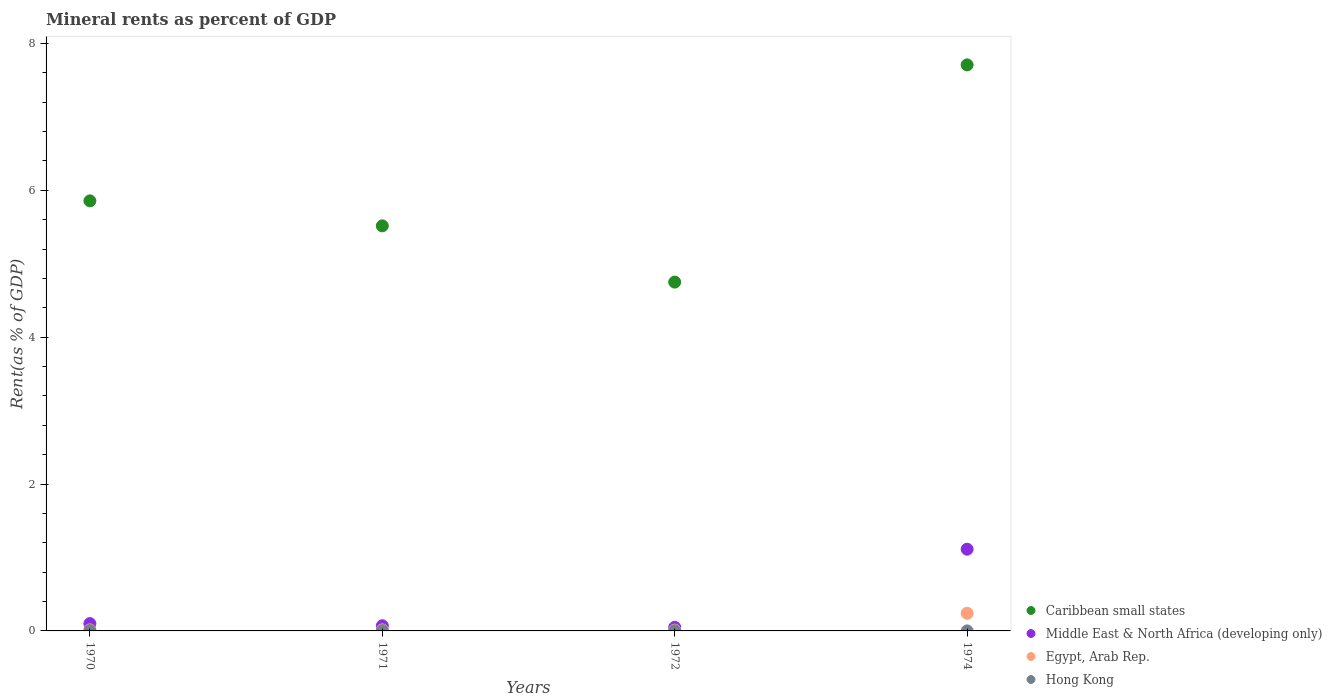Is the number of dotlines equal to the number of legend labels?
Your answer should be compact. Yes. What is the mineral rent in Caribbean small states in 1972?
Keep it short and to the point. 4.75. Across all years, what is the maximum mineral rent in Middle East & North Africa (developing only)?
Offer a very short reply. 1.11. Across all years, what is the minimum mineral rent in Hong Kong?
Your response must be concise. 0. In which year was the mineral rent in Egypt, Arab Rep. maximum?
Provide a short and direct response. 1974. What is the total mineral rent in Egypt, Arab Rep. in the graph?
Make the answer very short. 0.28. What is the difference between the mineral rent in Egypt, Arab Rep. in 1972 and that in 1974?
Provide a short and direct response. -0.23. What is the difference between the mineral rent in Middle East & North Africa (developing only) in 1971 and the mineral rent in Hong Kong in 1974?
Keep it short and to the point. 0.07. What is the average mineral rent in Middle East & North Africa (developing only) per year?
Offer a terse response. 0.33. In the year 1974, what is the difference between the mineral rent in Caribbean small states and mineral rent in Egypt, Arab Rep.?
Your response must be concise. 7.47. In how many years, is the mineral rent in Hong Kong greater than 4.8 %?
Make the answer very short. 0. What is the ratio of the mineral rent in Hong Kong in 1971 to that in 1974?
Offer a very short reply. 9.86. What is the difference between the highest and the second highest mineral rent in Egypt, Arab Rep.?
Give a very brief answer. 0.23. What is the difference between the highest and the lowest mineral rent in Caribbean small states?
Keep it short and to the point. 2.96. In how many years, is the mineral rent in Hong Kong greater than the average mineral rent in Hong Kong taken over all years?
Offer a very short reply. 2. Is the sum of the mineral rent in Middle East & North Africa (developing only) in 1972 and 1974 greater than the maximum mineral rent in Caribbean small states across all years?
Make the answer very short. No. Is it the case that in every year, the sum of the mineral rent in Middle East & North Africa (developing only) and mineral rent in Hong Kong  is greater than the mineral rent in Caribbean small states?
Make the answer very short. No. Is the mineral rent in Middle East & North Africa (developing only) strictly greater than the mineral rent in Caribbean small states over the years?
Provide a succinct answer. No. How many dotlines are there?
Provide a succinct answer. 4. How many years are there in the graph?
Offer a very short reply. 4. Are the values on the major ticks of Y-axis written in scientific E-notation?
Provide a succinct answer. No. What is the title of the graph?
Offer a terse response. Mineral rents as percent of GDP. What is the label or title of the Y-axis?
Your answer should be very brief. Rent(as % of GDP). What is the Rent(as % of GDP) in Caribbean small states in 1970?
Provide a short and direct response. 5.86. What is the Rent(as % of GDP) in Middle East & North Africa (developing only) in 1970?
Your response must be concise. 0.1. What is the Rent(as % of GDP) of Egypt, Arab Rep. in 1970?
Your answer should be compact. 0.01. What is the Rent(as % of GDP) in Hong Kong in 1970?
Give a very brief answer. 0. What is the Rent(as % of GDP) of Caribbean small states in 1971?
Give a very brief answer. 5.52. What is the Rent(as % of GDP) in Middle East & North Africa (developing only) in 1971?
Keep it short and to the point. 0.07. What is the Rent(as % of GDP) in Egypt, Arab Rep. in 1971?
Your answer should be compact. 0.02. What is the Rent(as % of GDP) of Hong Kong in 1971?
Your answer should be very brief. 0. What is the Rent(as % of GDP) of Caribbean small states in 1972?
Ensure brevity in your answer.  4.75. What is the Rent(as % of GDP) in Middle East & North Africa (developing only) in 1972?
Your answer should be very brief. 0.05. What is the Rent(as % of GDP) of Egypt, Arab Rep. in 1972?
Your answer should be very brief. 0.01. What is the Rent(as % of GDP) of Hong Kong in 1972?
Make the answer very short. 0. What is the Rent(as % of GDP) of Caribbean small states in 1974?
Offer a very short reply. 7.71. What is the Rent(as % of GDP) of Middle East & North Africa (developing only) in 1974?
Ensure brevity in your answer.  1.11. What is the Rent(as % of GDP) in Egypt, Arab Rep. in 1974?
Offer a terse response. 0.24. What is the Rent(as % of GDP) of Hong Kong in 1974?
Your response must be concise. 0. Across all years, what is the maximum Rent(as % of GDP) of Caribbean small states?
Offer a very short reply. 7.71. Across all years, what is the maximum Rent(as % of GDP) of Middle East & North Africa (developing only)?
Offer a terse response. 1.11. Across all years, what is the maximum Rent(as % of GDP) of Egypt, Arab Rep.?
Give a very brief answer. 0.24. Across all years, what is the maximum Rent(as % of GDP) of Hong Kong?
Your response must be concise. 0. Across all years, what is the minimum Rent(as % of GDP) of Caribbean small states?
Your answer should be compact. 4.75. Across all years, what is the minimum Rent(as % of GDP) of Middle East & North Africa (developing only)?
Your answer should be compact. 0.05. Across all years, what is the minimum Rent(as % of GDP) in Egypt, Arab Rep.?
Your response must be concise. 0.01. Across all years, what is the minimum Rent(as % of GDP) in Hong Kong?
Give a very brief answer. 0. What is the total Rent(as % of GDP) in Caribbean small states in the graph?
Your answer should be compact. 23.83. What is the total Rent(as % of GDP) in Middle East & North Africa (developing only) in the graph?
Ensure brevity in your answer.  1.33. What is the total Rent(as % of GDP) of Egypt, Arab Rep. in the graph?
Give a very brief answer. 0.28. What is the total Rent(as % of GDP) in Hong Kong in the graph?
Your answer should be compact. 0.01. What is the difference between the Rent(as % of GDP) of Caribbean small states in 1970 and that in 1971?
Your answer should be very brief. 0.34. What is the difference between the Rent(as % of GDP) of Middle East & North Africa (developing only) in 1970 and that in 1971?
Your answer should be very brief. 0.03. What is the difference between the Rent(as % of GDP) in Egypt, Arab Rep. in 1970 and that in 1971?
Provide a short and direct response. -0. What is the difference between the Rent(as % of GDP) of Hong Kong in 1970 and that in 1971?
Give a very brief answer. 0. What is the difference between the Rent(as % of GDP) in Caribbean small states in 1970 and that in 1972?
Offer a terse response. 1.11. What is the difference between the Rent(as % of GDP) of Middle East & North Africa (developing only) in 1970 and that in 1972?
Your answer should be very brief. 0.05. What is the difference between the Rent(as % of GDP) in Egypt, Arab Rep. in 1970 and that in 1972?
Provide a short and direct response. 0. What is the difference between the Rent(as % of GDP) in Hong Kong in 1970 and that in 1972?
Your response must be concise. 0. What is the difference between the Rent(as % of GDP) of Caribbean small states in 1970 and that in 1974?
Offer a very short reply. -1.85. What is the difference between the Rent(as % of GDP) in Middle East & North Africa (developing only) in 1970 and that in 1974?
Offer a very short reply. -1.01. What is the difference between the Rent(as % of GDP) in Egypt, Arab Rep. in 1970 and that in 1974?
Offer a very short reply. -0.23. What is the difference between the Rent(as % of GDP) of Hong Kong in 1970 and that in 1974?
Your answer should be very brief. 0. What is the difference between the Rent(as % of GDP) of Caribbean small states in 1971 and that in 1972?
Your response must be concise. 0.77. What is the difference between the Rent(as % of GDP) of Middle East & North Africa (developing only) in 1971 and that in 1972?
Keep it short and to the point. 0.02. What is the difference between the Rent(as % of GDP) of Egypt, Arab Rep. in 1971 and that in 1972?
Your answer should be very brief. 0. What is the difference between the Rent(as % of GDP) of Hong Kong in 1971 and that in 1972?
Your answer should be very brief. 0. What is the difference between the Rent(as % of GDP) in Caribbean small states in 1971 and that in 1974?
Provide a short and direct response. -2.19. What is the difference between the Rent(as % of GDP) in Middle East & North Africa (developing only) in 1971 and that in 1974?
Make the answer very short. -1.04. What is the difference between the Rent(as % of GDP) in Egypt, Arab Rep. in 1971 and that in 1974?
Ensure brevity in your answer.  -0.23. What is the difference between the Rent(as % of GDP) in Hong Kong in 1971 and that in 1974?
Keep it short and to the point. 0. What is the difference between the Rent(as % of GDP) in Caribbean small states in 1972 and that in 1974?
Ensure brevity in your answer.  -2.96. What is the difference between the Rent(as % of GDP) of Middle East & North Africa (developing only) in 1972 and that in 1974?
Your response must be concise. -1.06. What is the difference between the Rent(as % of GDP) of Egypt, Arab Rep. in 1972 and that in 1974?
Provide a short and direct response. -0.23. What is the difference between the Rent(as % of GDP) in Hong Kong in 1972 and that in 1974?
Your response must be concise. 0. What is the difference between the Rent(as % of GDP) of Caribbean small states in 1970 and the Rent(as % of GDP) of Middle East & North Africa (developing only) in 1971?
Make the answer very short. 5.79. What is the difference between the Rent(as % of GDP) of Caribbean small states in 1970 and the Rent(as % of GDP) of Egypt, Arab Rep. in 1971?
Offer a terse response. 5.84. What is the difference between the Rent(as % of GDP) in Caribbean small states in 1970 and the Rent(as % of GDP) in Hong Kong in 1971?
Ensure brevity in your answer.  5.85. What is the difference between the Rent(as % of GDP) in Middle East & North Africa (developing only) in 1970 and the Rent(as % of GDP) in Egypt, Arab Rep. in 1971?
Ensure brevity in your answer.  0.08. What is the difference between the Rent(as % of GDP) of Middle East & North Africa (developing only) in 1970 and the Rent(as % of GDP) of Hong Kong in 1971?
Ensure brevity in your answer.  0.1. What is the difference between the Rent(as % of GDP) in Egypt, Arab Rep. in 1970 and the Rent(as % of GDP) in Hong Kong in 1971?
Your answer should be very brief. 0.01. What is the difference between the Rent(as % of GDP) of Caribbean small states in 1970 and the Rent(as % of GDP) of Middle East & North Africa (developing only) in 1972?
Your answer should be very brief. 5.81. What is the difference between the Rent(as % of GDP) of Caribbean small states in 1970 and the Rent(as % of GDP) of Egypt, Arab Rep. in 1972?
Offer a very short reply. 5.84. What is the difference between the Rent(as % of GDP) of Caribbean small states in 1970 and the Rent(as % of GDP) of Hong Kong in 1972?
Offer a terse response. 5.85. What is the difference between the Rent(as % of GDP) in Middle East & North Africa (developing only) in 1970 and the Rent(as % of GDP) in Egypt, Arab Rep. in 1972?
Offer a very short reply. 0.09. What is the difference between the Rent(as % of GDP) in Middle East & North Africa (developing only) in 1970 and the Rent(as % of GDP) in Hong Kong in 1972?
Provide a succinct answer. 0.1. What is the difference between the Rent(as % of GDP) of Egypt, Arab Rep. in 1970 and the Rent(as % of GDP) of Hong Kong in 1972?
Your response must be concise. 0.01. What is the difference between the Rent(as % of GDP) in Caribbean small states in 1970 and the Rent(as % of GDP) in Middle East & North Africa (developing only) in 1974?
Offer a terse response. 4.74. What is the difference between the Rent(as % of GDP) in Caribbean small states in 1970 and the Rent(as % of GDP) in Egypt, Arab Rep. in 1974?
Your answer should be very brief. 5.62. What is the difference between the Rent(as % of GDP) in Caribbean small states in 1970 and the Rent(as % of GDP) in Hong Kong in 1974?
Provide a short and direct response. 5.86. What is the difference between the Rent(as % of GDP) in Middle East & North Africa (developing only) in 1970 and the Rent(as % of GDP) in Egypt, Arab Rep. in 1974?
Offer a very short reply. -0.14. What is the difference between the Rent(as % of GDP) in Middle East & North Africa (developing only) in 1970 and the Rent(as % of GDP) in Hong Kong in 1974?
Provide a succinct answer. 0.1. What is the difference between the Rent(as % of GDP) of Egypt, Arab Rep. in 1970 and the Rent(as % of GDP) of Hong Kong in 1974?
Ensure brevity in your answer.  0.01. What is the difference between the Rent(as % of GDP) in Caribbean small states in 1971 and the Rent(as % of GDP) in Middle East & North Africa (developing only) in 1972?
Ensure brevity in your answer.  5.47. What is the difference between the Rent(as % of GDP) in Caribbean small states in 1971 and the Rent(as % of GDP) in Egypt, Arab Rep. in 1972?
Provide a succinct answer. 5.5. What is the difference between the Rent(as % of GDP) in Caribbean small states in 1971 and the Rent(as % of GDP) in Hong Kong in 1972?
Provide a succinct answer. 5.51. What is the difference between the Rent(as % of GDP) in Middle East & North Africa (developing only) in 1971 and the Rent(as % of GDP) in Egypt, Arab Rep. in 1972?
Provide a short and direct response. 0.06. What is the difference between the Rent(as % of GDP) of Middle East & North Africa (developing only) in 1971 and the Rent(as % of GDP) of Hong Kong in 1972?
Provide a succinct answer. 0.07. What is the difference between the Rent(as % of GDP) of Egypt, Arab Rep. in 1971 and the Rent(as % of GDP) of Hong Kong in 1972?
Provide a short and direct response. 0.01. What is the difference between the Rent(as % of GDP) in Caribbean small states in 1971 and the Rent(as % of GDP) in Middle East & North Africa (developing only) in 1974?
Offer a terse response. 4.4. What is the difference between the Rent(as % of GDP) of Caribbean small states in 1971 and the Rent(as % of GDP) of Egypt, Arab Rep. in 1974?
Give a very brief answer. 5.28. What is the difference between the Rent(as % of GDP) in Caribbean small states in 1971 and the Rent(as % of GDP) in Hong Kong in 1974?
Your response must be concise. 5.52. What is the difference between the Rent(as % of GDP) of Middle East & North Africa (developing only) in 1971 and the Rent(as % of GDP) of Egypt, Arab Rep. in 1974?
Make the answer very short. -0.17. What is the difference between the Rent(as % of GDP) in Middle East & North Africa (developing only) in 1971 and the Rent(as % of GDP) in Hong Kong in 1974?
Your answer should be very brief. 0.07. What is the difference between the Rent(as % of GDP) in Egypt, Arab Rep. in 1971 and the Rent(as % of GDP) in Hong Kong in 1974?
Keep it short and to the point. 0.01. What is the difference between the Rent(as % of GDP) in Caribbean small states in 1972 and the Rent(as % of GDP) in Middle East & North Africa (developing only) in 1974?
Offer a very short reply. 3.64. What is the difference between the Rent(as % of GDP) in Caribbean small states in 1972 and the Rent(as % of GDP) in Egypt, Arab Rep. in 1974?
Make the answer very short. 4.51. What is the difference between the Rent(as % of GDP) in Caribbean small states in 1972 and the Rent(as % of GDP) in Hong Kong in 1974?
Offer a terse response. 4.75. What is the difference between the Rent(as % of GDP) of Middle East & North Africa (developing only) in 1972 and the Rent(as % of GDP) of Egypt, Arab Rep. in 1974?
Keep it short and to the point. -0.19. What is the difference between the Rent(as % of GDP) in Middle East & North Africa (developing only) in 1972 and the Rent(as % of GDP) in Hong Kong in 1974?
Make the answer very short. 0.05. What is the difference between the Rent(as % of GDP) of Egypt, Arab Rep. in 1972 and the Rent(as % of GDP) of Hong Kong in 1974?
Give a very brief answer. 0.01. What is the average Rent(as % of GDP) in Caribbean small states per year?
Give a very brief answer. 5.96. What is the average Rent(as % of GDP) of Middle East & North Africa (developing only) per year?
Keep it short and to the point. 0.33. What is the average Rent(as % of GDP) of Egypt, Arab Rep. per year?
Make the answer very short. 0.07. What is the average Rent(as % of GDP) in Hong Kong per year?
Offer a very short reply. 0. In the year 1970, what is the difference between the Rent(as % of GDP) in Caribbean small states and Rent(as % of GDP) in Middle East & North Africa (developing only)?
Make the answer very short. 5.76. In the year 1970, what is the difference between the Rent(as % of GDP) in Caribbean small states and Rent(as % of GDP) in Egypt, Arab Rep.?
Offer a terse response. 5.84. In the year 1970, what is the difference between the Rent(as % of GDP) in Caribbean small states and Rent(as % of GDP) in Hong Kong?
Offer a terse response. 5.85. In the year 1970, what is the difference between the Rent(as % of GDP) of Middle East & North Africa (developing only) and Rent(as % of GDP) of Egypt, Arab Rep.?
Your answer should be compact. 0.08. In the year 1970, what is the difference between the Rent(as % of GDP) in Middle East & North Africa (developing only) and Rent(as % of GDP) in Hong Kong?
Make the answer very short. 0.1. In the year 1970, what is the difference between the Rent(as % of GDP) in Egypt, Arab Rep. and Rent(as % of GDP) in Hong Kong?
Provide a succinct answer. 0.01. In the year 1971, what is the difference between the Rent(as % of GDP) in Caribbean small states and Rent(as % of GDP) in Middle East & North Africa (developing only)?
Your response must be concise. 5.45. In the year 1971, what is the difference between the Rent(as % of GDP) in Caribbean small states and Rent(as % of GDP) in Egypt, Arab Rep.?
Keep it short and to the point. 5.5. In the year 1971, what is the difference between the Rent(as % of GDP) in Caribbean small states and Rent(as % of GDP) in Hong Kong?
Provide a succinct answer. 5.51. In the year 1971, what is the difference between the Rent(as % of GDP) of Middle East & North Africa (developing only) and Rent(as % of GDP) of Egypt, Arab Rep.?
Provide a succinct answer. 0.06. In the year 1971, what is the difference between the Rent(as % of GDP) in Middle East & North Africa (developing only) and Rent(as % of GDP) in Hong Kong?
Keep it short and to the point. 0.07. In the year 1971, what is the difference between the Rent(as % of GDP) in Egypt, Arab Rep. and Rent(as % of GDP) in Hong Kong?
Your answer should be compact. 0.01. In the year 1972, what is the difference between the Rent(as % of GDP) in Caribbean small states and Rent(as % of GDP) in Middle East & North Africa (developing only)?
Offer a terse response. 4.7. In the year 1972, what is the difference between the Rent(as % of GDP) of Caribbean small states and Rent(as % of GDP) of Egypt, Arab Rep.?
Your answer should be very brief. 4.74. In the year 1972, what is the difference between the Rent(as % of GDP) in Caribbean small states and Rent(as % of GDP) in Hong Kong?
Ensure brevity in your answer.  4.75. In the year 1972, what is the difference between the Rent(as % of GDP) of Middle East & North Africa (developing only) and Rent(as % of GDP) of Egypt, Arab Rep.?
Offer a terse response. 0.04. In the year 1972, what is the difference between the Rent(as % of GDP) in Middle East & North Africa (developing only) and Rent(as % of GDP) in Hong Kong?
Provide a succinct answer. 0.05. In the year 1972, what is the difference between the Rent(as % of GDP) of Egypt, Arab Rep. and Rent(as % of GDP) of Hong Kong?
Give a very brief answer. 0.01. In the year 1974, what is the difference between the Rent(as % of GDP) in Caribbean small states and Rent(as % of GDP) in Middle East & North Africa (developing only)?
Your answer should be very brief. 6.6. In the year 1974, what is the difference between the Rent(as % of GDP) of Caribbean small states and Rent(as % of GDP) of Egypt, Arab Rep.?
Provide a succinct answer. 7.47. In the year 1974, what is the difference between the Rent(as % of GDP) in Caribbean small states and Rent(as % of GDP) in Hong Kong?
Offer a terse response. 7.71. In the year 1974, what is the difference between the Rent(as % of GDP) in Middle East & North Africa (developing only) and Rent(as % of GDP) in Egypt, Arab Rep.?
Keep it short and to the point. 0.87. In the year 1974, what is the difference between the Rent(as % of GDP) in Middle East & North Africa (developing only) and Rent(as % of GDP) in Hong Kong?
Ensure brevity in your answer.  1.11. In the year 1974, what is the difference between the Rent(as % of GDP) in Egypt, Arab Rep. and Rent(as % of GDP) in Hong Kong?
Give a very brief answer. 0.24. What is the ratio of the Rent(as % of GDP) of Caribbean small states in 1970 to that in 1971?
Offer a terse response. 1.06. What is the ratio of the Rent(as % of GDP) in Middle East & North Africa (developing only) in 1970 to that in 1971?
Your answer should be very brief. 1.42. What is the ratio of the Rent(as % of GDP) in Egypt, Arab Rep. in 1970 to that in 1971?
Your response must be concise. 0.98. What is the ratio of the Rent(as % of GDP) of Hong Kong in 1970 to that in 1971?
Ensure brevity in your answer.  1.17. What is the ratio of the Rent(as % of GDP) of Caribbean small states in 1970 to that in 1972?
Keep it short and to the point. 1.23. What is the ratio of the Rent(as % of GDP) in Middle East & North Africa (developing only) in 1970 to that in 1972?
Provide a succinct answer. 2.05. What is the ratio of the Rent(as % of GDP) of Egypt, Arab Rep. in 1970 to that in 1972?
Your answer should be very brief. 1.26. What is the ratio of the Rent(as % of GDP) in Hong Kong in 1970 to that in 1972?
Provide a short and direct response. 2.49. What is the ratio of the Rent(as % of GDP) in Caribbean small states in 1970 to that in 1974?
Make the answer very short. 0.76. What is the ratio of the Rent(as % of GDP) of Middle East & North Africa (developing only) in 1970 to that in 1974?
Your answer should be very brief. 0.09. What is the ratio of the Rent(as % of GDP) in Egypt, Arab Rep. in 1970 to that in 1974?
Give a very brief answer. 0.06. What is the ratio of the Rent(as % of GDP) in Hong Kong in 1970 to that in 1974?
Your answer should be compact. 11.52. What is the ratio of the Rent(as % of GDP) in Caribbean small states in 1971 to that in 1972?
Provide a short and direct response. 1.16. What is the ratio of the Rent(as % of GDP) of Middle East & North Africa (developing only) in 1971 to that in 1972?
Provide a succinct answer. 1.44. What is the ratio of the Rent(as % of GDP) in Egypt, Arab Rep. in 1971 to that in 1972?
Provide a succinct answer. 1.28. What is the ratio of the Rent(as % of GDP) in Hong Kong in 1971 to that in 1972?
Your response must be concise. 2.14. What is the ratio of the Rent(as % of GDP) in Caribbean small states in 1971 to that in 1974?
Your answer should be compact. 0.72. What is the ratio of the Rent(as % of GDP) of Middle East & North Africa (developing only) in 1971 to that in 1974?
Offer a very short reply. 0.06. What is the ratio of the Rent(as % of GDP) of Egypt, Arab Rep. in 1971 to that in 1974?
Offer a terse response. 0.06. What is the ratio of the Rent(as % of GDP) in Hong Kong in 1971 to that in 1974?
Provide a short and direct response. 9.86. What is the ratio of the Rent(as % of GDP) of Caribbean small states in 1972 to that in 1974?
Give a very brief answer. 0.62. What is the ratio of the Rent(as % of GDP) of Middle East & North Africa (developing only) in 1972 to that in 1974?
Provide a short and direct response. 0.04. What is the ratio of the Rent(as % of GDP) in Egypt, Arab Rep. in 1972 to that in 1974?
Your response must be concise. 0.05. What is the ratio of the Rent(as % of GDP) in Hong Kong in 1972 to that in 1974?
Ensure brevity in your answer.  4.62. What is the difference between the highest and the second highest Rent(as % of GDP) of Caribbean small states?
Provide a succinct answer. 1.85. What is the difference between the highest and the second highest Rent(as % of GDP) of Middle East & North Africa (developing only)?
Offer a terse response. 1.01. What is the difference between the highest and the second highest Rent(as % of GDP) in Egypt, Arab Rep.?
Provide a short and direct response. 0.23. What is the difference between the highest and the second highest Rent(as % of GDP) in Hong Kong?
Offer a terse response. 0. What is the difference between the highest and the lowest Rent(as % of GDP) of Caribbean small states?
Ensure brevity in your answer.  2.96. What is the difference between the highest and the lowest Rent(as % of GDP) of Middle East & North Africa (developing only)?
Keep it short and to the point. 1.06. What is the difference between the highest and the lowest Rent(as % of GDP) in Egypt, Arab Rep.?
Offer a very short reply. 0.23. What is the difference between the highest and the lowest Rent(as % of GDP) of Hong Kong?
Your answer should be compact. 0. 